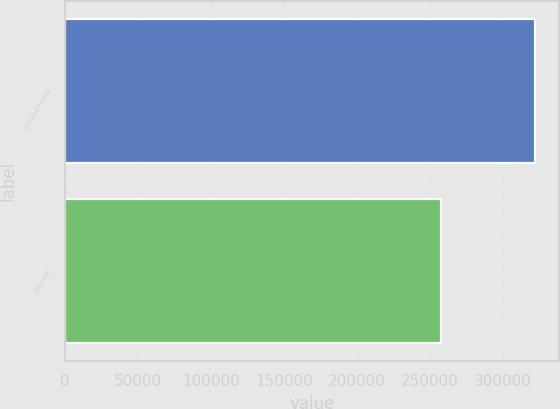Convert chart. <chart><loc_0><loc_0><loc_500><loc_500><bar_chart><fcel>Income taxes<fcel>Interest<nl><fcel>322018<fcel>257640<nl></chart> 